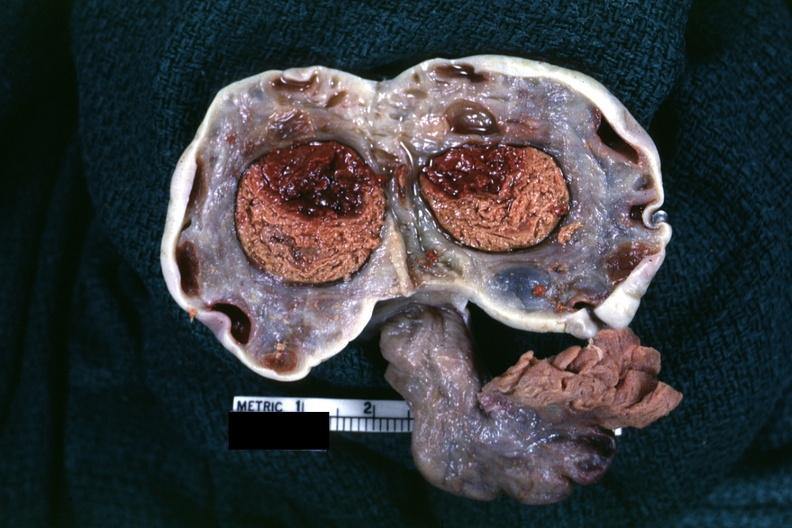s female reproductive present?
Answer the question using a single word or phrase. Yes 